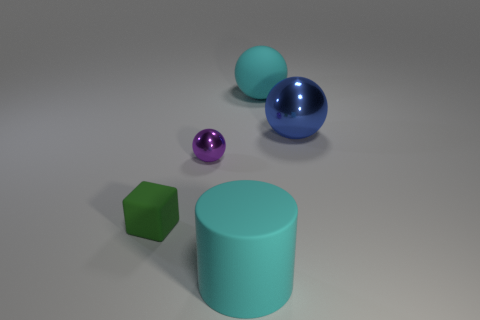Add 2 brown rubber spheres. How many objects exist? 7 Subtract all blocks. How many objects are left? 4 Subtract all gray matte spheres. Subtract all tiny purple shiny spheres. How many objects are left? 4 Add 5 tiny rubber blocks. How many tiny rubber blocks are left? 6 Add 1 small yellow metal balls. How many small yellow metal balls exist? 1 Subtract 0 brown blocks. How many objects are left? 5 